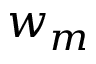Convert formula to latex. <formula><loc_0><loc_0><loc_500><loc_500>w _ { m }</formula> 